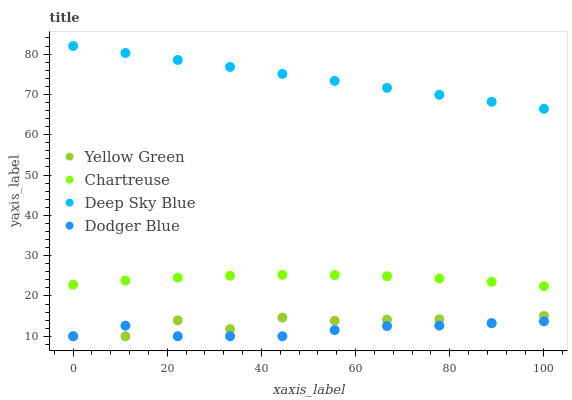Does Dodger Blue have the minimum area under the curve?
Answer yes or no. Yes. Does Deep Sky Blue have the maximum area under the curve?
Answer yes or no. Yes. Does Yellow Green have the minimum area under the curve?
Answer yes or no. No. Does Yellow Green have the maximum area under the curve?
Answer yes or no. No. Is Deep Sky Blue the smoothest?
Answer yes or no. Yes. Is Yellow Green the roughest?
Answer yes or no. Yes. Is Dodger Blue the smoothest?
Answer yes or no. No. Is Dodger Blue the roughest?
Answer yes or no. No. Does Dodger Blue have the lowest value?
Answer yes or no. Yes. Does Deep Sky Blue have the lowest value?
Answer yes or no. No. Does Deep Sky Blue have the highest value?
Answer yes or no. Yes. Does Yellow Green have the highest value?
Answer yes or no. No. Is Dodger Blue less than Chartreuse?
Answer yes or no. Yes. Is Deep Sky Blue greater than Dodger Blue?
Answer yes or no. Yes. Does Yellow Green intersect Dodger Blue?
Answer yes or no. Yes. Is Yellow Green less than Dodger Blue?
Answer yes or no. No. Is Yellow Green greater than Dodger Blue?
Answer yes or no. No. Does Dodger Blue intersect Chartreuse?
Answer yes or no. No. 